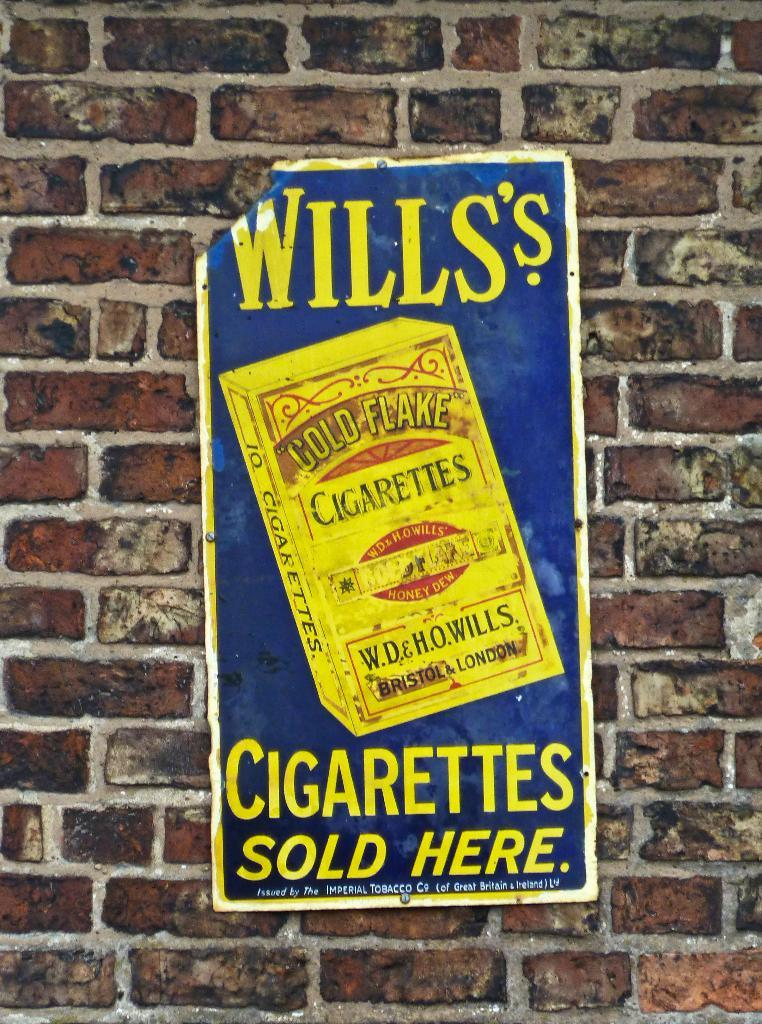<image>
Give a short and clear explanation of the subsequent image. A vintage sign advertising Wills's Cigarettes sold here. 